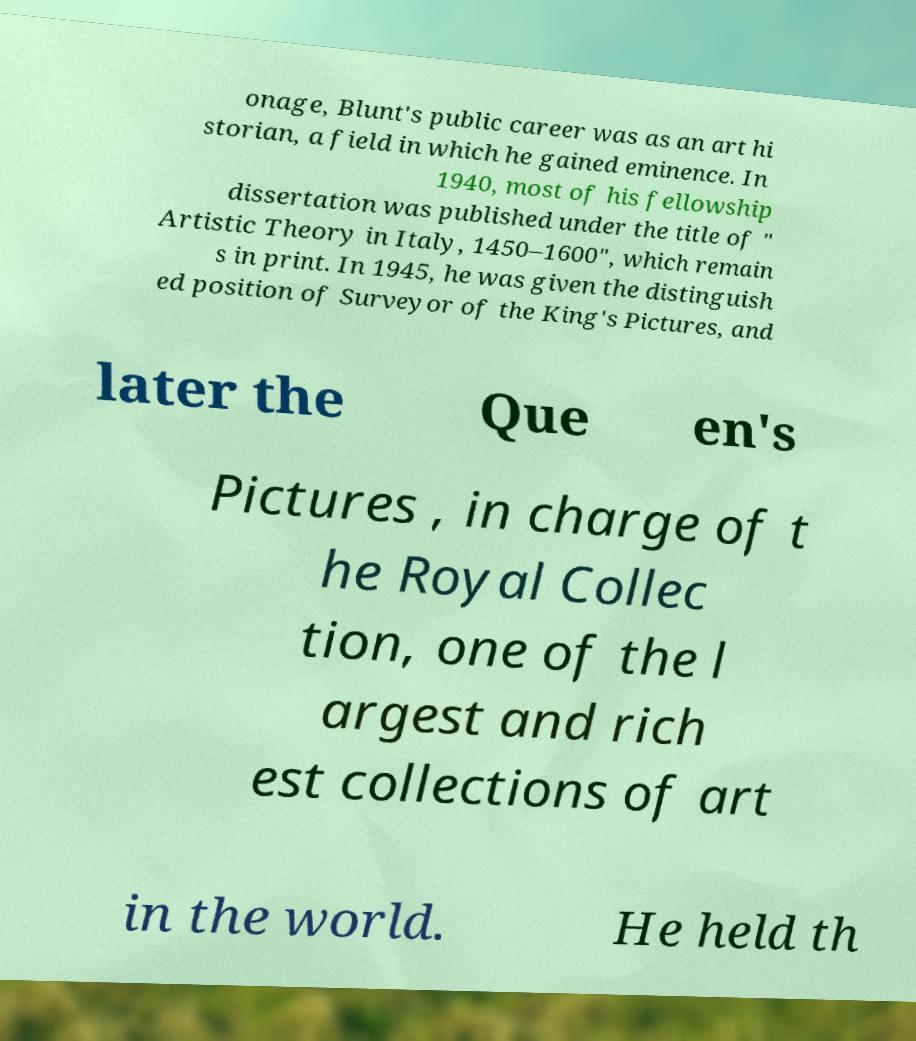Please read and relay the text visible in this image. What does it say? onage, Blunt's public career was as an art hi storian, a field in which he gained eminence. In 1940, most of his fellowship dissertation was published under the title of " Artistic Theory in Italy, 1450–1600", which remain s in print. In 1945, he was given the distinguish ed position of Surveyor of the King's Pictures, and later the Que en's Pictures , in charge of t he Royal Collec tion, one of the l argest and rich est collections of art in the world. He held th 